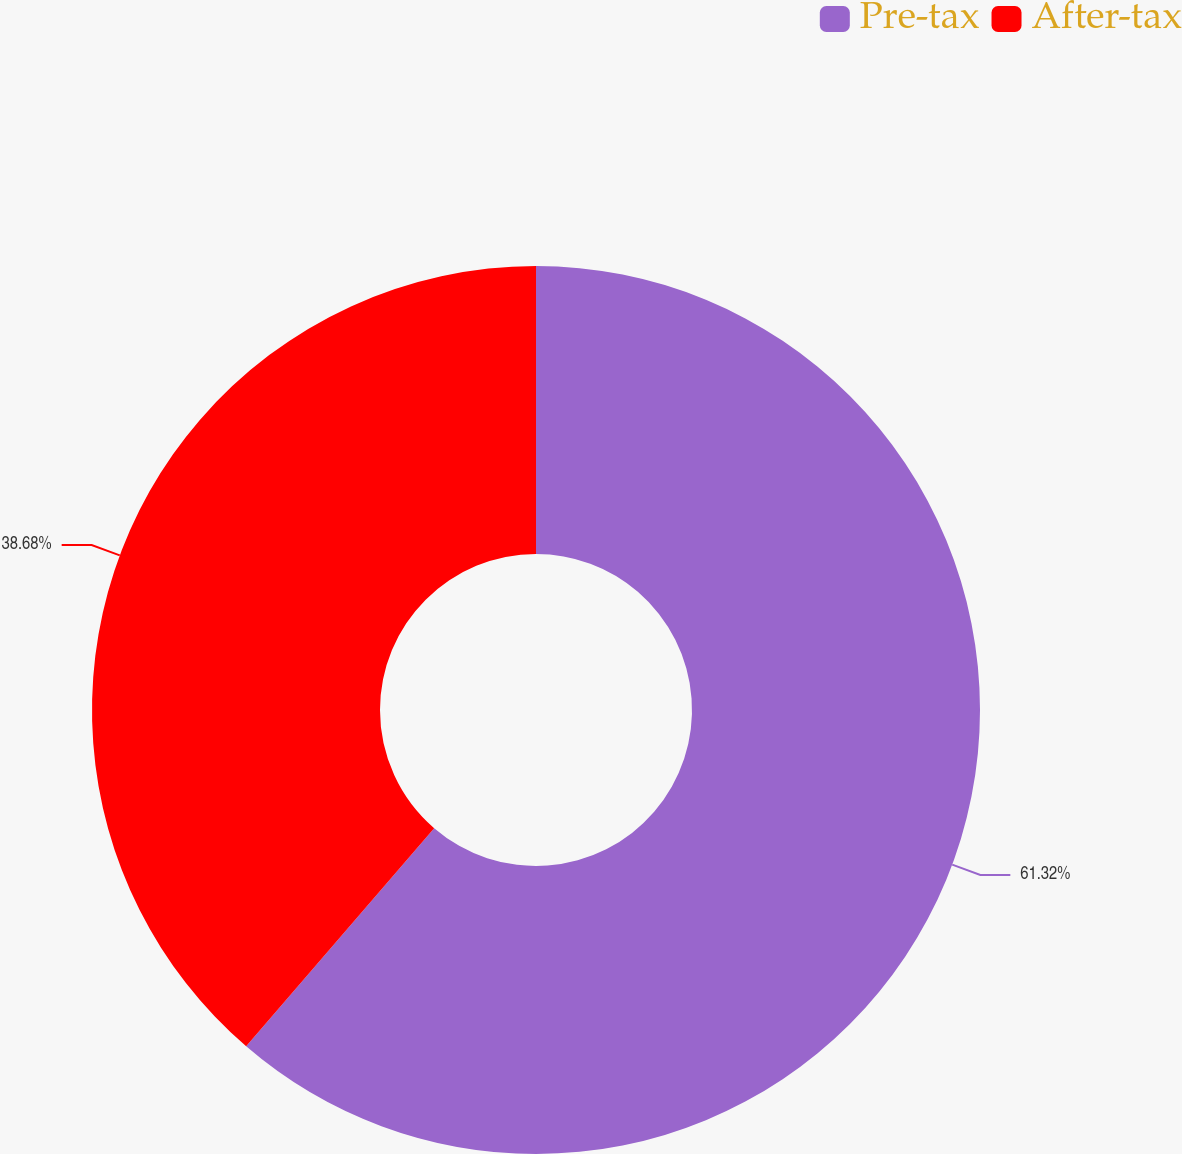Convert chart to OTSL. <chart><loc_0><loc_0><loc_500><loc_500><pie_chart><fcel>Pre-tax<fcel>After-tax<nl><fcel>61.32%<fcel>38.68%<nl></chart> 